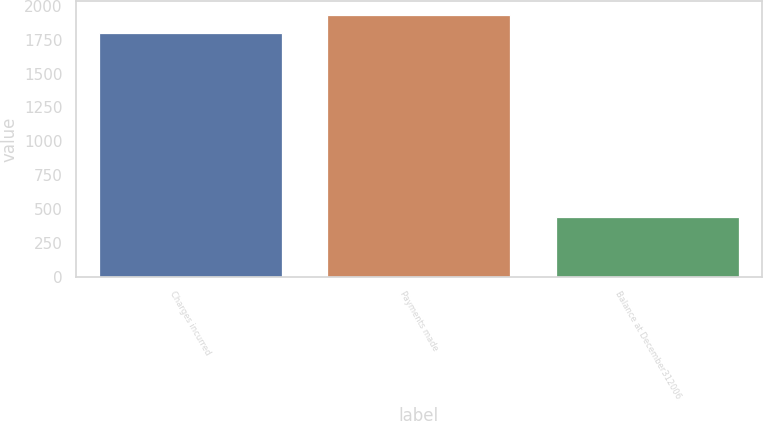<chart> <loc_0><loc_0><loc_500><loc_500><bar_chart><fcel>Charges incurred<fcel>Payments made<fcel>Balance at December312006<nl><fcel>1800<fcel>1935.9<fcel>441<nl></chart> 